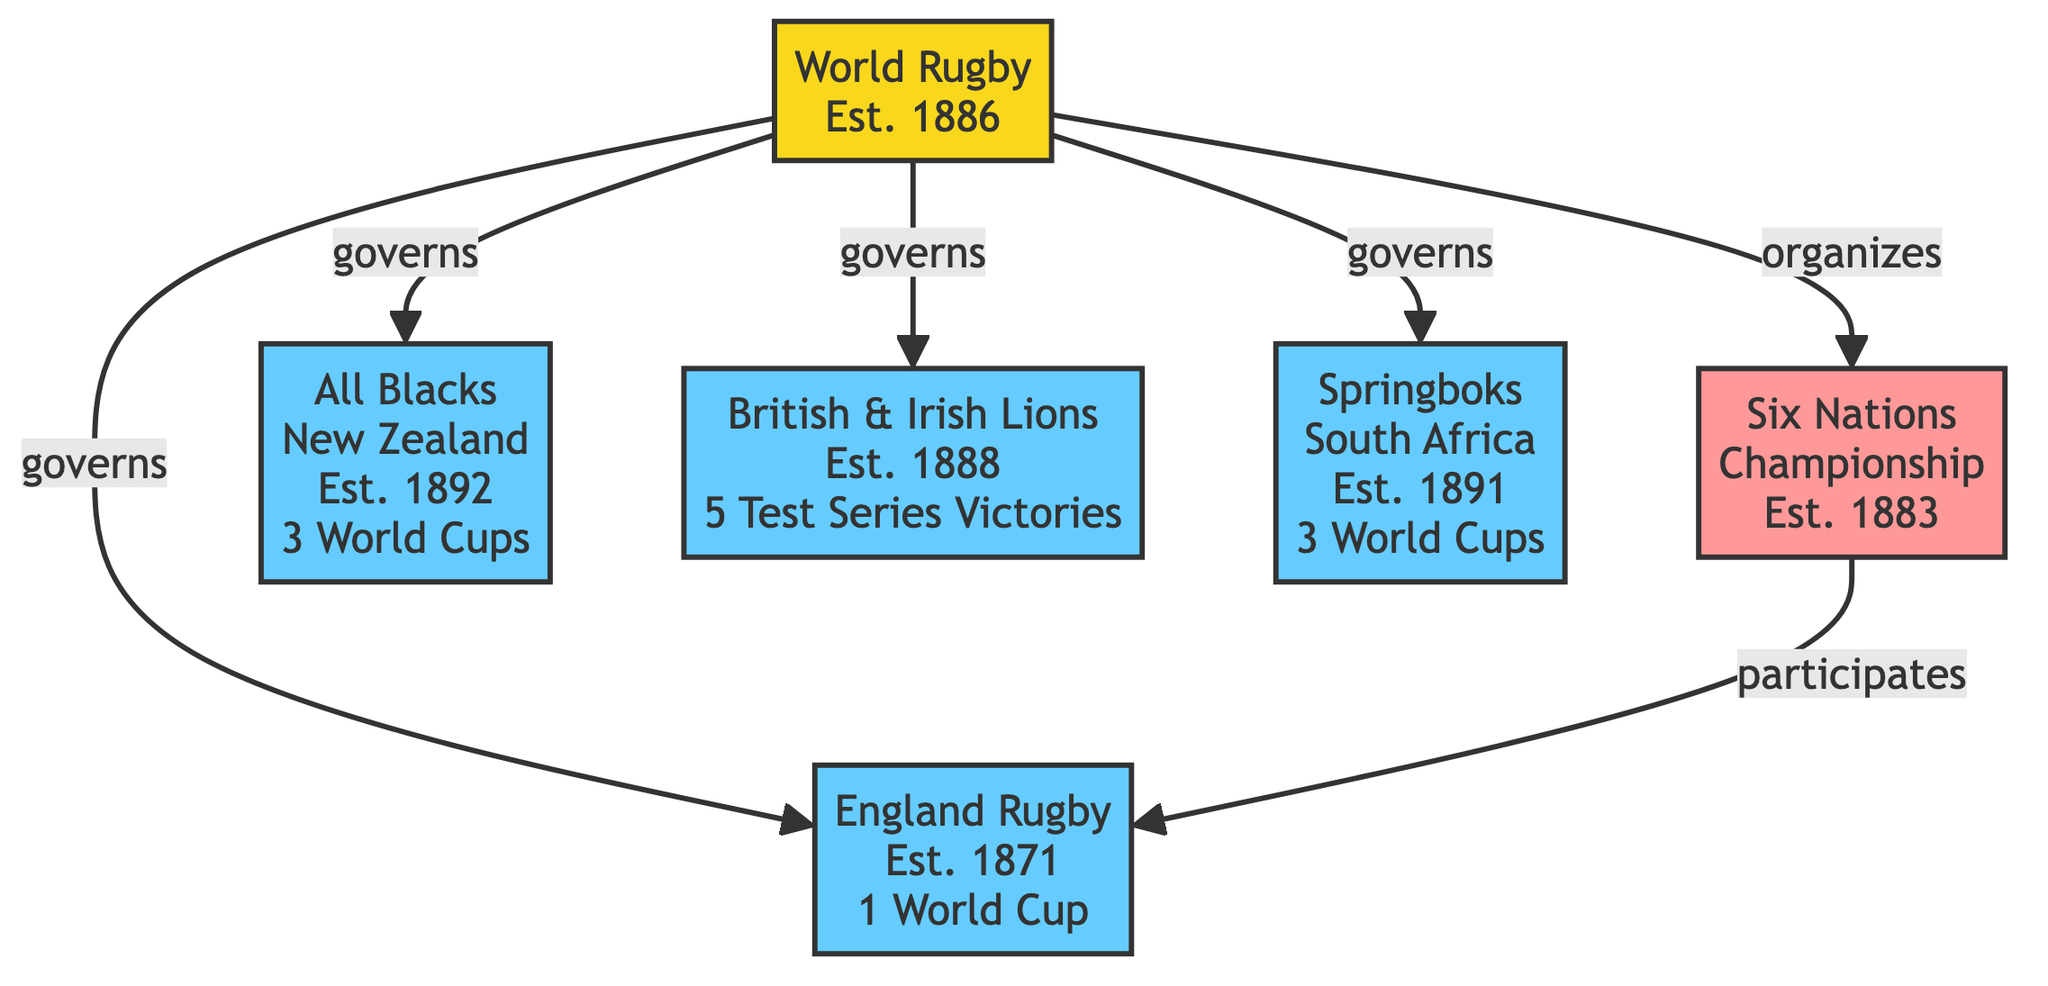What is the year of establishment for the All Blacks? The All Blacks node states they were established in 1892. This information is directly mentioned next to their name in the diagram.
Answer: 1892 How many Rugby World Cup victories do the Springboks have? The Springboks node lists three Rugby World Cup victories in the achievements section. This is shown clearly alongside their name.
Answer: 3 Which organization governs all the teams shown in the diagram? The World Rugby node connects to all team nodes with a "governs" relationship, indicating that it is the governing body for all the teams represented.
Answer: World Rugby In what year was the Six Nations Championship established? The Six Nations Championship node specifies that it was established in 1883, providing this detail directly.
Answer: 1883 How many Test Series victories do the British & Irish Lions have? The achievements section of the British & Irish Lions node specifies that they have a total of five Test Series victories. This information is clear in the diagram.
Answer: 5 Which team participates in the Six Nations Championship? The connection from the Six Nations Championship to the England Rugby node indicates that England Rugby participates in this tournament. This relation is explicitly depicted in the diagram.
Answer: England Rugby How many teams are governed by World Rugby? The diagram shows five teams (All Blacks, England Rugby, British & Irish Lions, Springboks) under the governance of World Rugby, which is evident from the connections leading from World Rugby to each team.
Answer: 4 What are the years when England Rugby won the Six Nations Championship? The achievements section for England Rugby lists several years alongside the "Six Nations Championship," and counting those provided gives the years directly.
Answer: 1910, 1912, 1913, 1921, 1934, 1953, 1991, 1992, 1995, 2000, 2001, 2003, 2016, 2017, 2020 Which tournament is organized by World Rugby? The diagram shows a direct connection from World Rugby to the Six Nations Championship with a "organizes" relationship, indicating that World Rugby is responsible for this tournament.
Answer: Six Nations Championship 